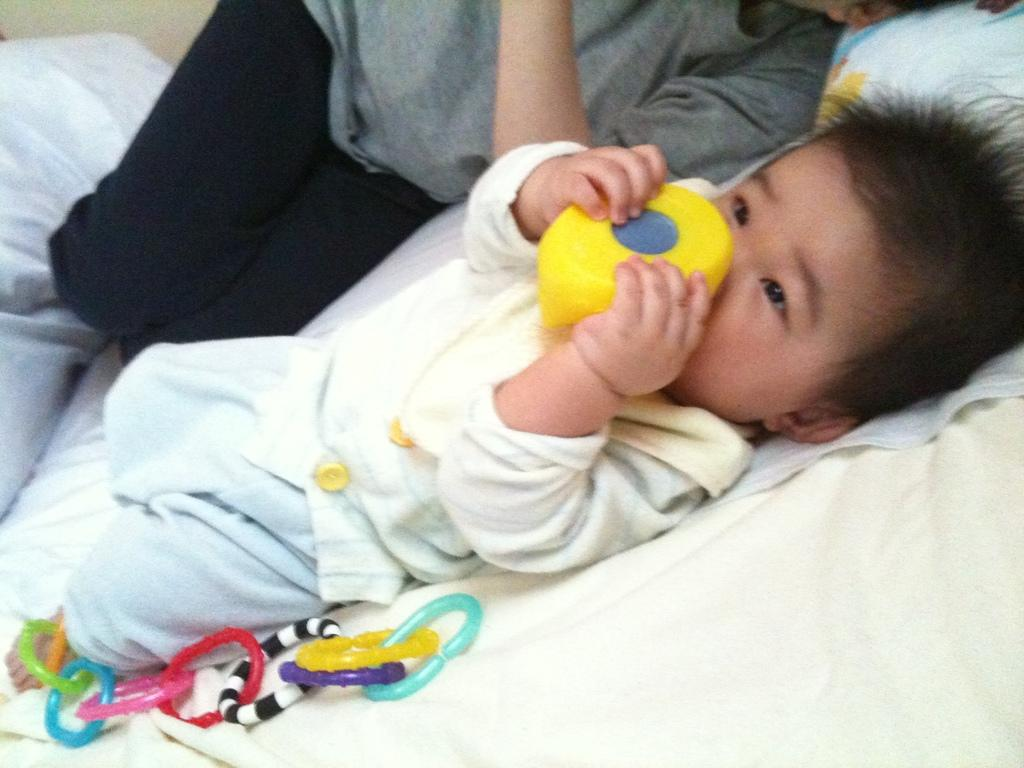What is the main subject of the image? The main subject of the image is a baby boy. Can you describe the setting in which the baby boy is located? There is a person lying on the bed in the image. What type of amusement can be seen in the image? There is no amusement present in the image; it features a baby boy and a person lying on a bed. What type of calendar is hanging on the wall in the image? There is no calendar visible in the image. What is the purpose of the bucket in the image? There is no bucket present in the image. 